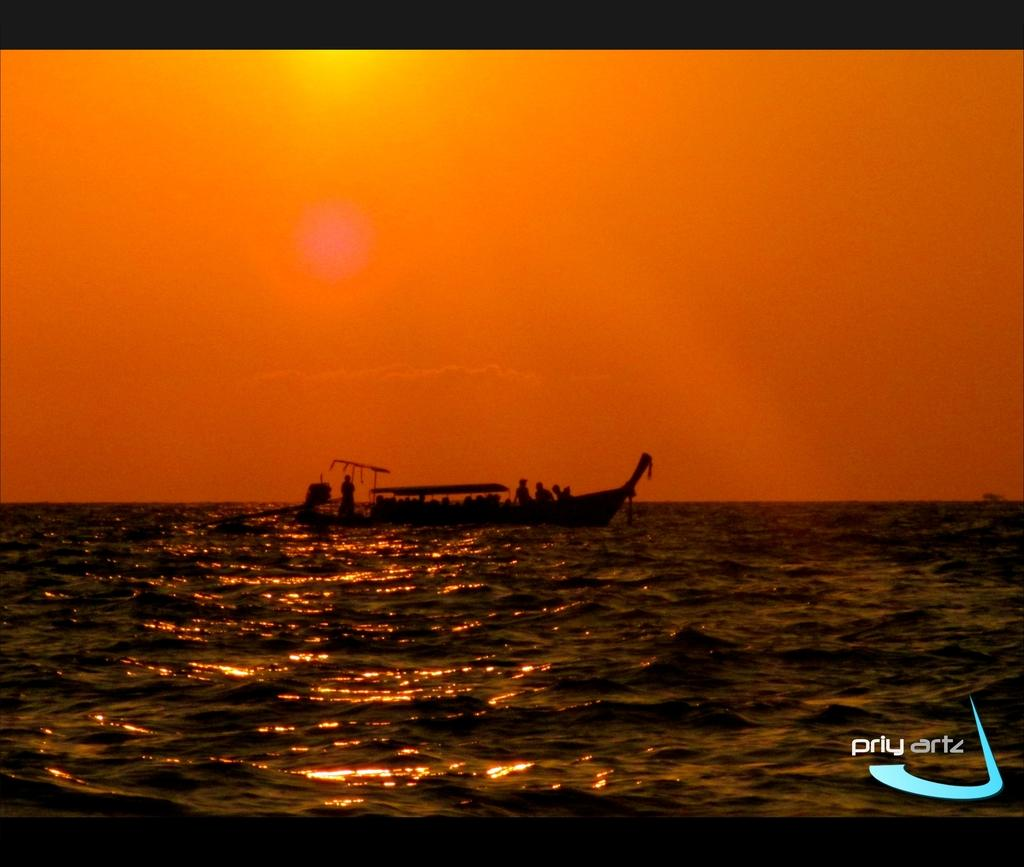What is the main subject of the image? The main subject of the image is water. What is on the water in the image? There is a boat on the water in the image. Who or what is inside the boat? There are people in the boat. What can be seen in the background of the image? The sky is visible in the background of the image. What type of paste is being used by the minister in the image? There is no minister or paste present in the image. 